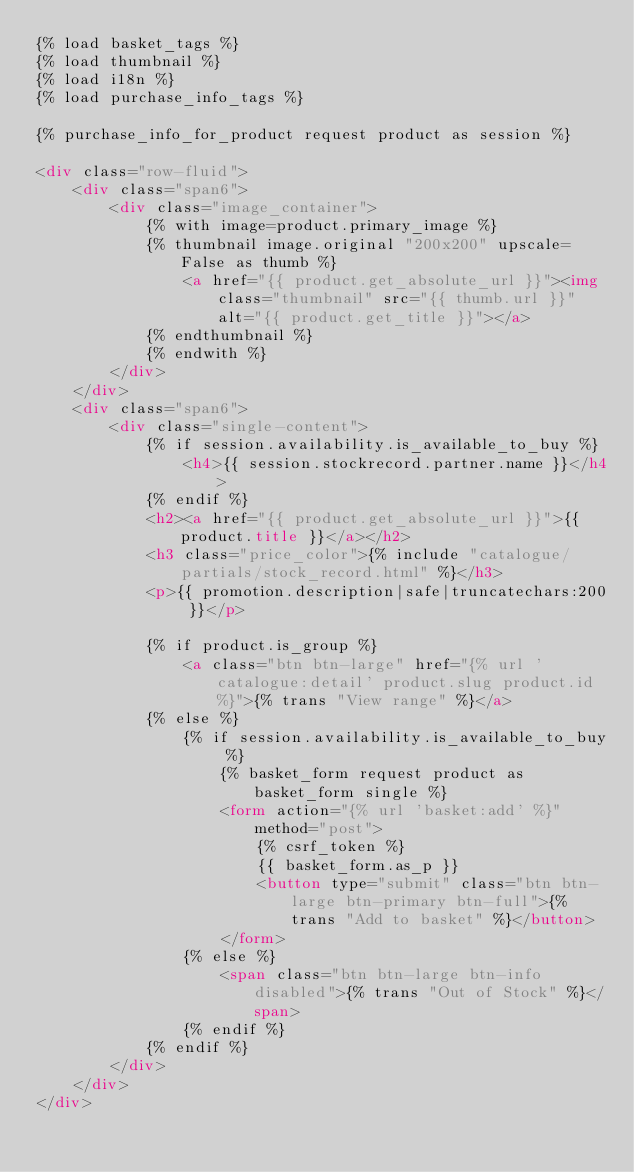<code> <loc_0><loc_0><loc_500><loc_500><_HTML_>{% load basket_tags %}
{% load thumbnail %}
{% load i18n %}
{% load purchase_info_tags %}

{% purchase_info_for_product request product as session %}

<div class="row-fluid">
    <div class="span6">
        <div class="image_container"> 
            {% with image=product.primary_image %}
            {% thumbnail image.original "200x200" upscale=False as thumb %}
                <a href="{{ product.get_absolute_url }}"><img class="thumbnail" src="{{ thumb.url }}" alt="{{ product.get_title }}"></a>
            {% endthumbnail %}
            {% endwith %}
        </div>    
    </div>
    <div class="span6">
        <div class="single-content">
            {% if session.availability.is_available_to_buy %}
                <h4>{{ session.stockrecord.partner.name }}</h4>
            {% endif %}
            <h2><a href="{{ product.get_absolute_url }}">{{ product.title }}</a></h2>
            <h3 class="price_color">{% include "catalogue/partials/stock_record.html" %}</h3>
            <p>{{ promotion.description|safe|truncatechars:200 }}</p>

            {% if product.is_group %}
                <a class="btn btn-large" href="{% url 'catalogue:detail' product.slug product.id %}">{% trans "View range" %}</a>
            {% else %}
                {% if session.availability.is_available_to_buy %}
                    {% basket_form request product as basket_form single %}
                    <form action="{% url 'basket:add' %}" method="post">
                        {% csrf_token %}
                        {{ basket_form.as_p }}
                        <button type="submit" class="btn btn-large btn-primary btn-full">{% trans "Add to basket" %}</button>
                    </form>
                {% else %}
                    <span class="btn btn-large btn-info disabled">{% trans "Out of Stock" %}</span>
                {% endif %}
            {% endif %}
        </div>
    </div>
</div>
</code> 